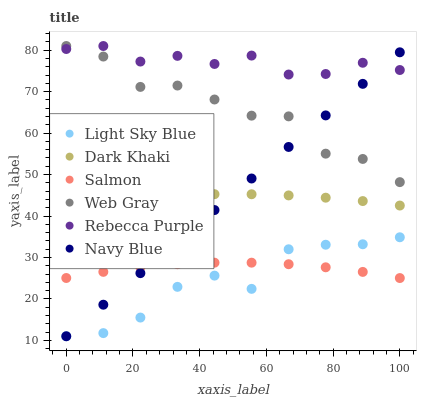Does Light Sky Blue have the minimum area under the curve?
Answer yes or no. Yes. Does Rebecca Purple have the maximum area under the curve?
Answer yes or no. Yes. Does Navy Blue have the minimum area under the curve?
Answer yes or no. No. Does Navy Blue have the maximum area under the curve?
Answer yes or no. No. Is Navy Blue the smoothest?
Answer yes or no. Yes. Is Web Gray the roughest?
Answer yes or no. Yes. Is Salmon the smoothest?
Answer yes or no. No. Is Salmon the roughest?
Answer yes or no. No. Does Navy Blue have the lowest value?
Answer yes or no. Yes. Does Salmon have the lowest value?
Answer yes or no. No. Does Rebecca Purple have the highest value?
Answer yes or no. Yes. Does Navy Blue have the highest value?
Answer yes or no. No. Is Dark Khaki less than Web Gray?
Answer yes or no. Yes. Is Web Gray greater than Salmon?
Answer yes or no. Yes. Does Web Gray intersect Rebecca Purple?
Answer yes or no. Yes. Is Web Gray less than Rebecca Purple?
Answer yes or no. No. Is Web Gray greater than Rebecca Purple?
Answer yes or no. No. Does Dark Khaki intersect Web Gray?
Answer yes or no. No. 